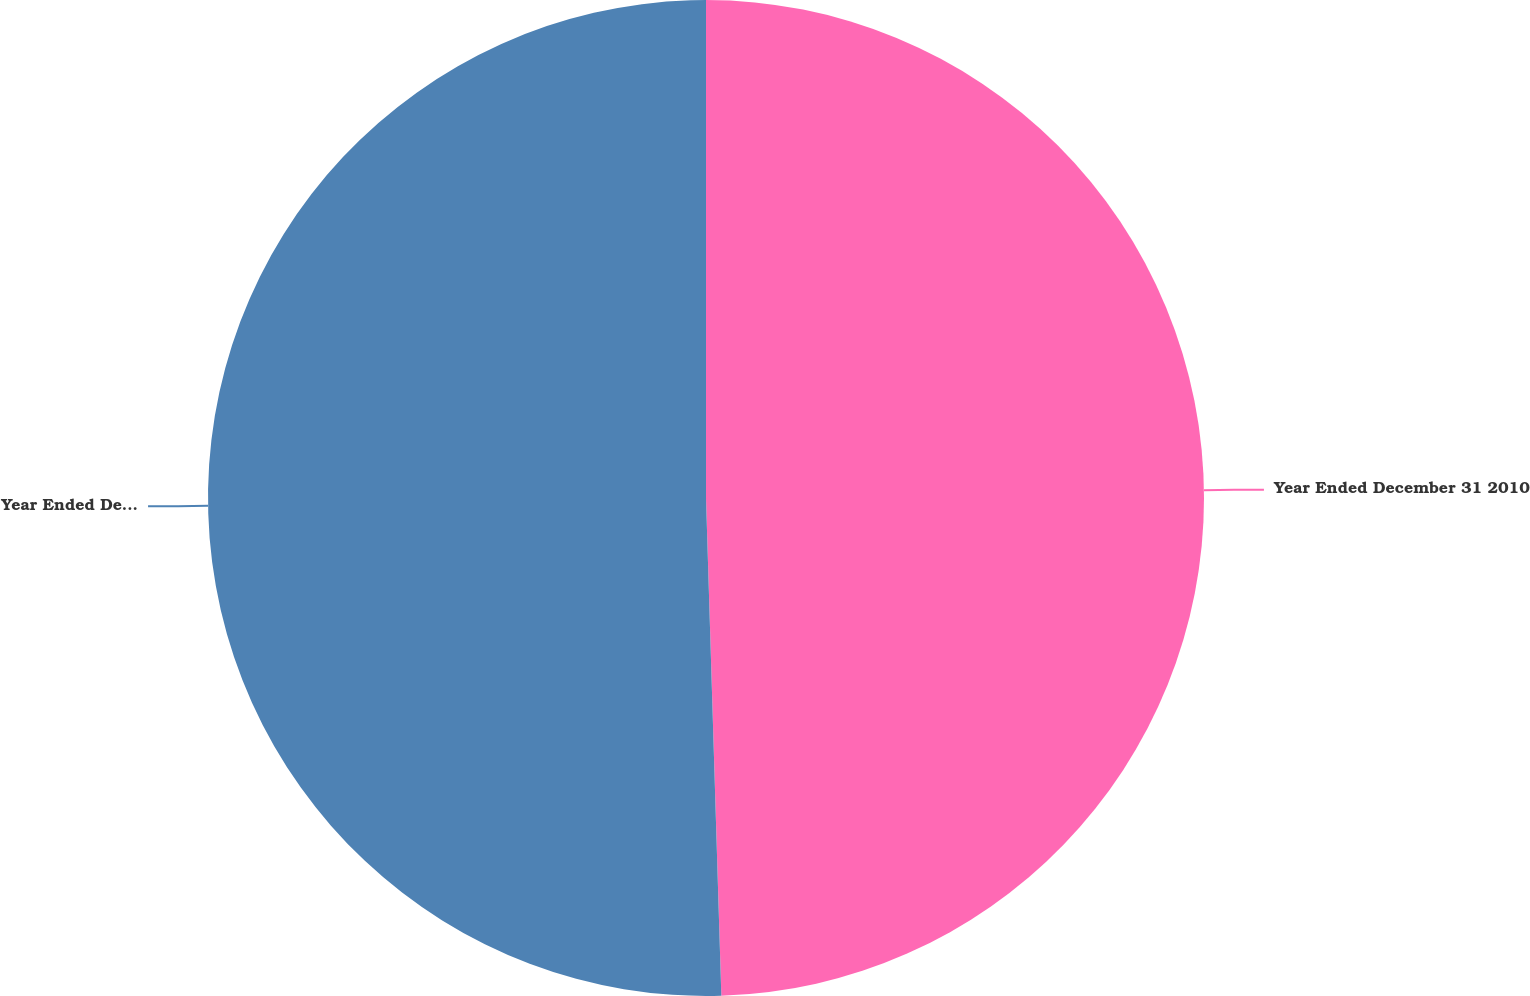Convert chart. <chart><loc_0><loc_0><loc_500><loc_500><pie_chart><fcel>Year Ended December 31 2010<fcel>Year Ended December 31 2009<nl><fcel>49.51%<fcel>50.49%<nl></chart> 